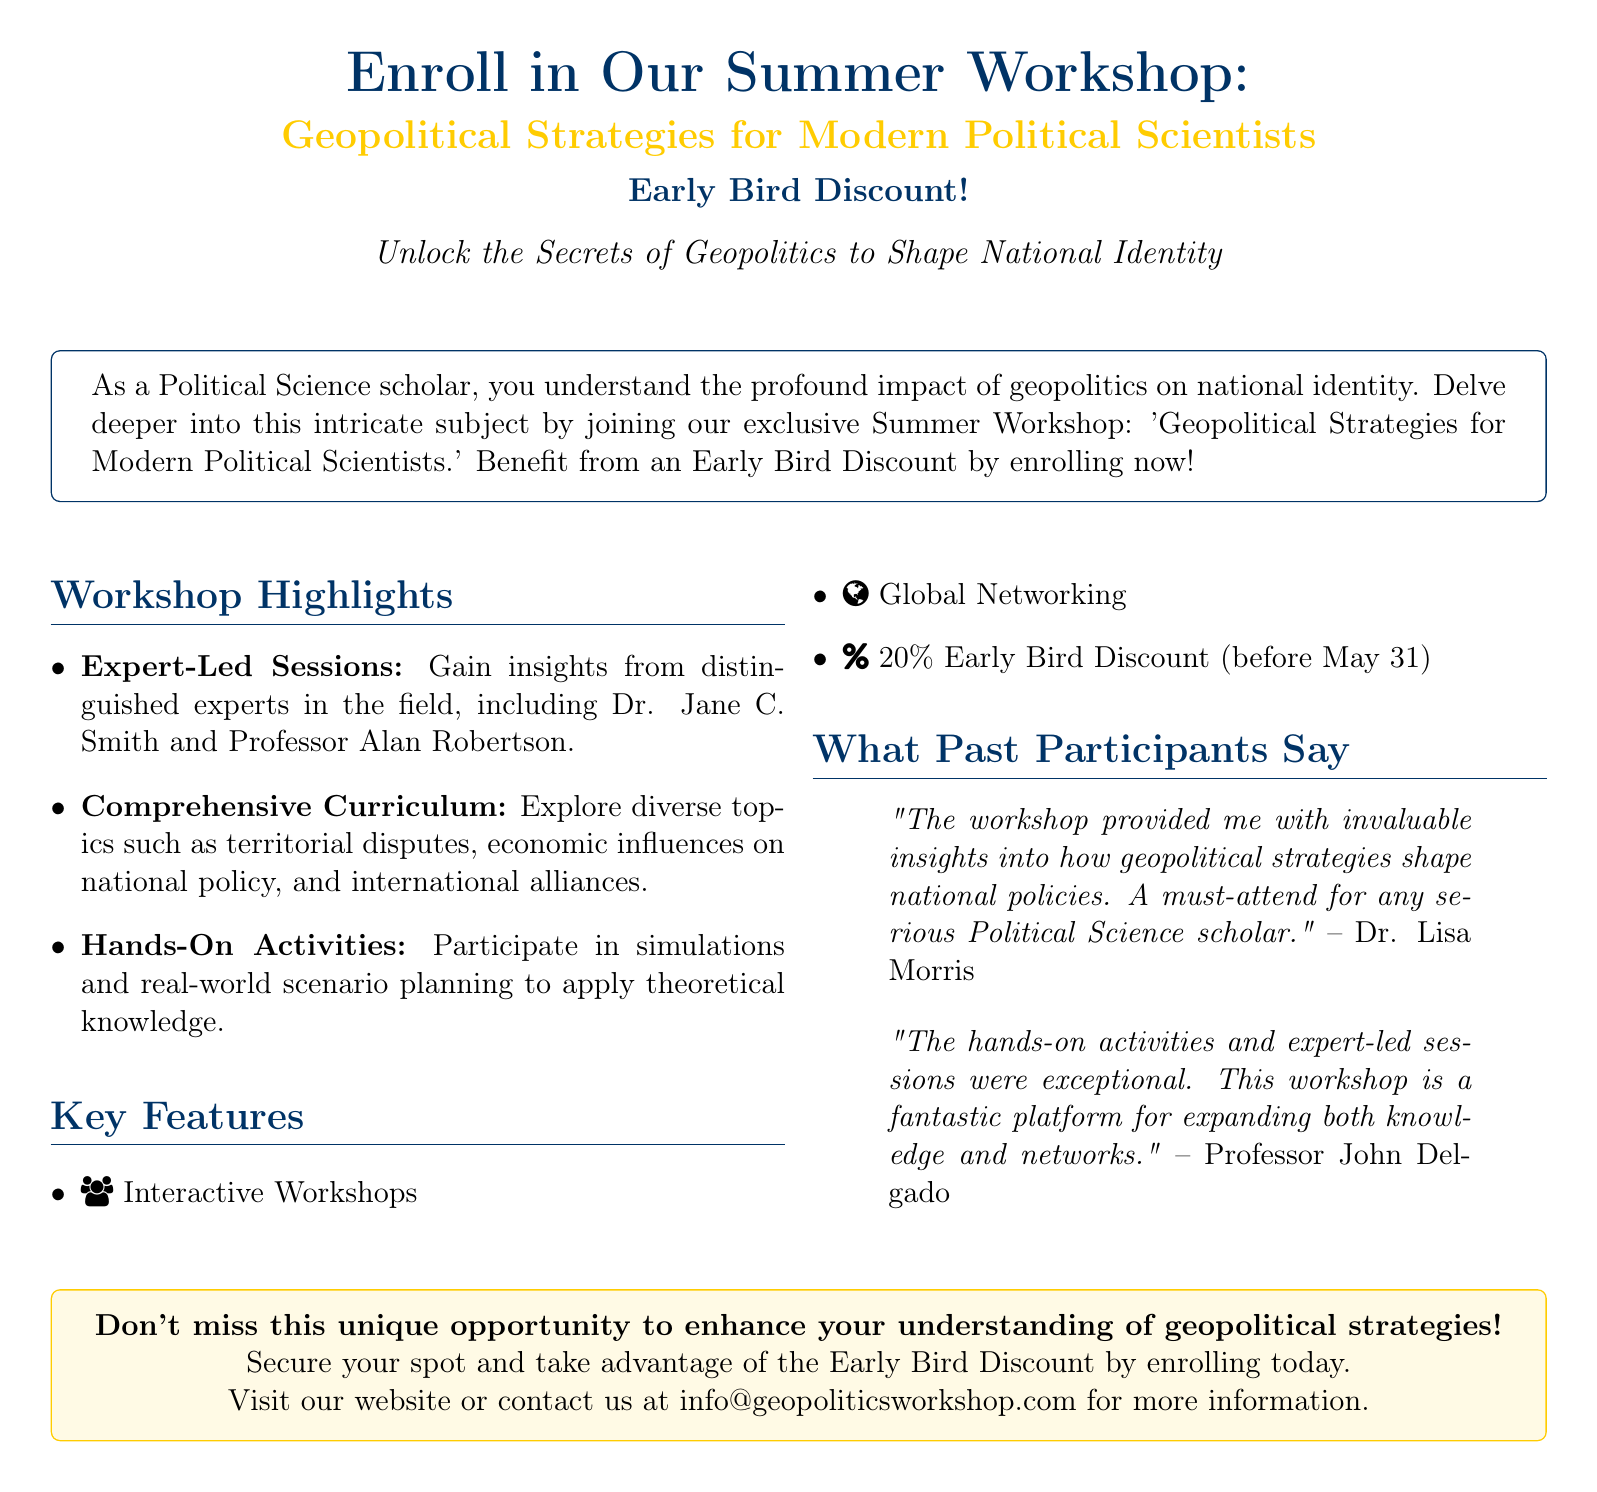What is the title of the workshop? The title of the workshop is specified in the main heading, emphasizing its focus on geopolitical strategies.
Answer: Geopolitical Strategies for Modern Political Scientists Who are the distinguished experts mentioned in the document? The document lists experts who will lead the sessions, highlighting their relevance to the workshop's content.
Answer: Dr. Jane C. Smith and Professor Alan Robertson What is the discount percentage for early enrollment? The document explicitly states the discount percentage for those who enroll before the specified date.
Answer: 20% When is the deadline for the Early Bird Discount? The document provides a specific date up to which the early bird discount applies, crucial for potential participants.
Answer: May 31 What type of activities can participants expect? The document describes the nature of engagement participants will have, reflecting the hands-on aspect of the workshop.
Answer: Simulations and real-world scenario planning What does Dr. Lisa Morris say about the workshop? The document contains a quote from Dr. Lisa Morris that reflects her positive experience and insights gained from the workshop.
Answer: "The workshop provided me with invaluable insights into how geopolitical strategies shape national policies." What is the importance of the workshop according to the quotes? The document includes participant testimonials that emphasize the workshop's significance in expanding knowledge and networking, underscoring its value.
Answer: A must-attend for any serious Political Science scholar What type of document is this? Based on the features such as promotional content and explicit call-to-action for enrollment, the type can be identified easily.
Answer: Advertisement 